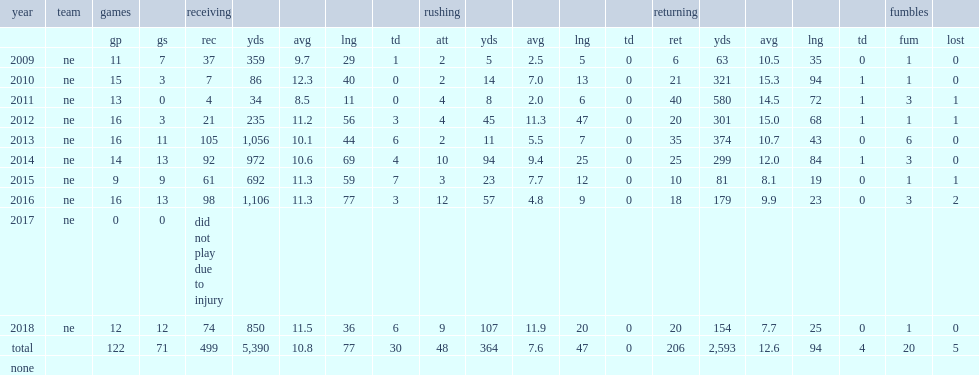How many receiving yards did julian edelman get in 2016? 1106.0. 